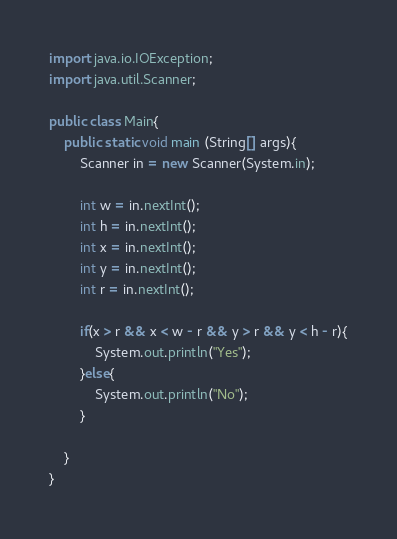Convert code to text. <code><loc_0><loc_0><loc_500><loc_500><_Java_>import java.io.IOException;
import java.util.Scanner;

public class Main{
	public static void main (String[] args){
		Scanner in = new Scanner(System.in);
		
		int w = in.nextInt();
		int h = in.nextInt();
		int x = in.nextInt();
		int y = in.nextInt();
		int r = in.nextInt();
		
		if(x > r && x < w - r && y > r && y < h - r){
			System.out.println("Yes");
		}else{
			System.out.println("No");
		}
		
	}
}</code> 